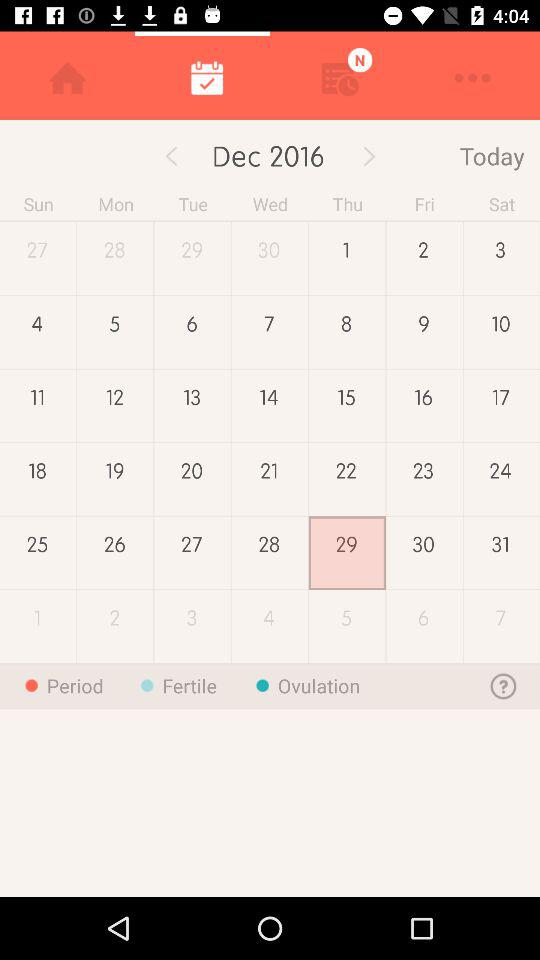What is the year? The year is 2016. 